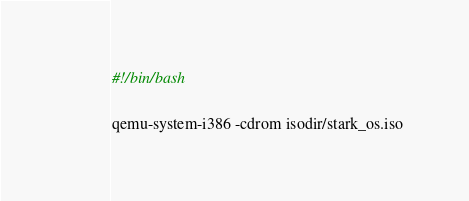<code> <loc_0><loc_0><loc_500><loc_500><_Bash_>#!/bin/bash

qemu-system-i386 -cdrom isodir/stark_os.iso
</code> 